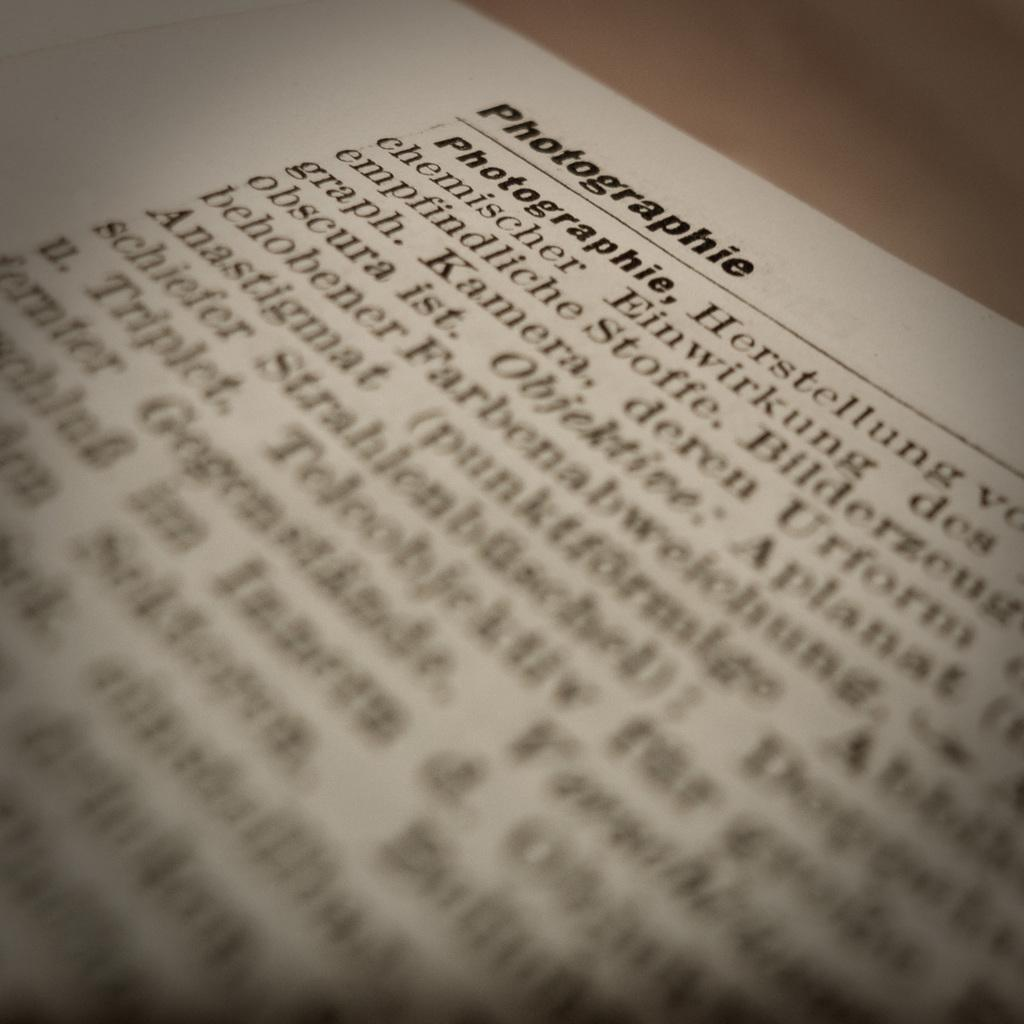<image>
Present a compact description of the photo's key features. a page of typed out words that is titled 'photographie' 